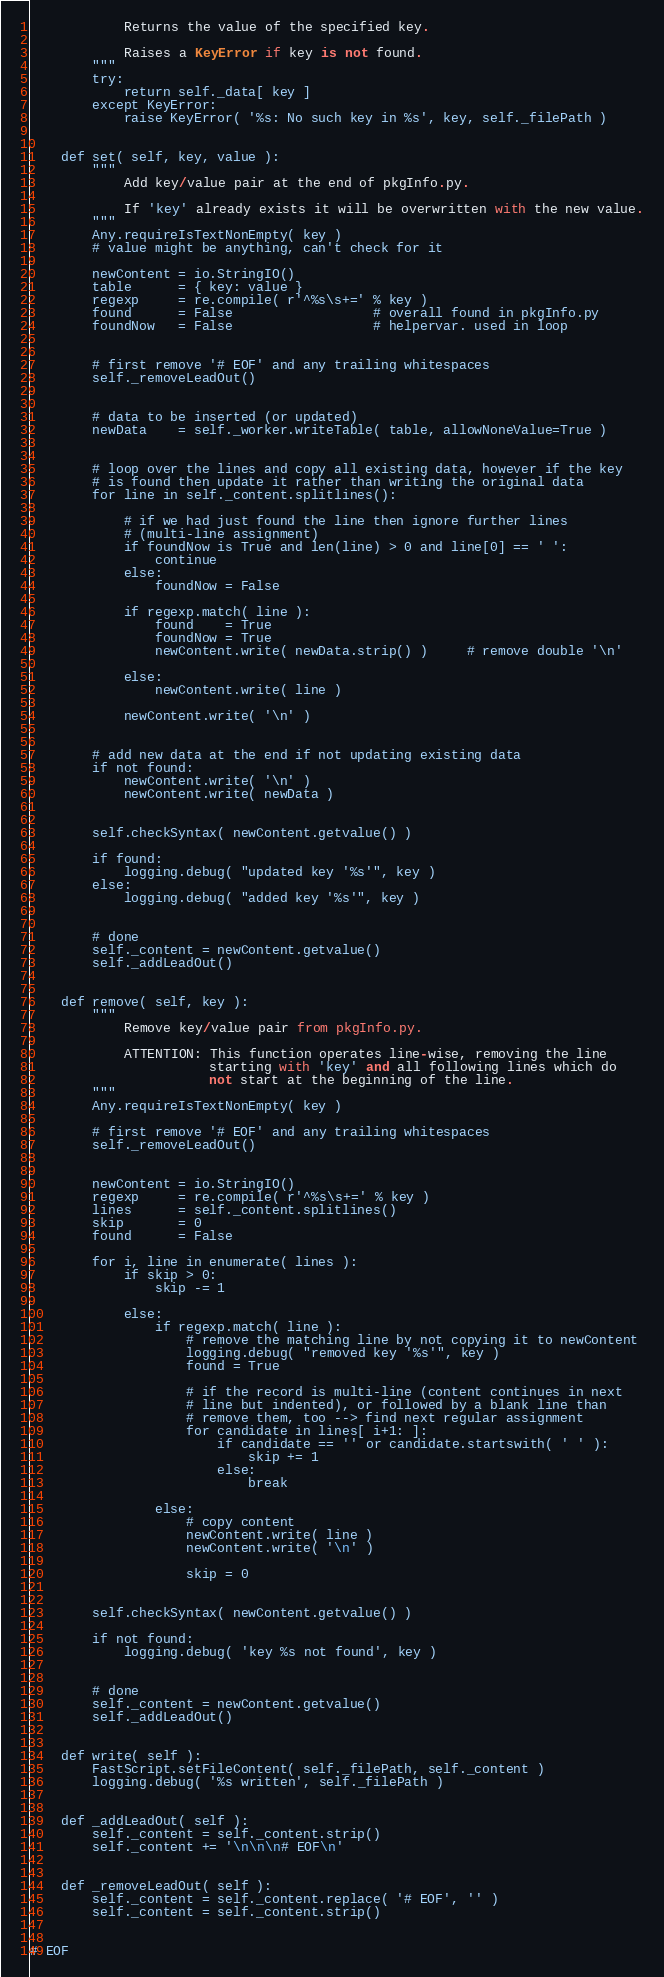Convert code to text. <code><loc_0><loc_0><loc_500><loc_500><_Python_>            Returns the value of the specified key.

            Raises a KeyError if key is not found.
        """
        try:
            return self._data[ key ]
        except KeyError:
            raise KeyError( '%s: No such key in %s', key, self._filePath )


    def set( self, key, value ):
        """
            Add key/value pair at the end of pkgInfo.py.

            If 'key' already exists it will be overwritten with the new value.
        """
        Any.requireIsTextNonEmpty( key )
        # value might be anything, can't check for it

        newContent = io.StringIO()
        table      = { key: value }
        regexp     = re.compile( r'^%s\s+=' % key )
        found      = False                  # overall found in pkgInfo.py
        foundNow   = False                  # helpervar. used in loop


        # first remove '# EOF' and any trailing whitespaces
        self._removeLeadOut()


        # data to be inserted (or updated)
        newData    = self._worker.writeTable( table, allowNoneValue=True )


        # loop over the lines and copy all existing data, however if the key
        # is found then update it rather than writing the original data
        for line in self._content.splitlines():

            # if we had just found the line then ignore further lines
            # (multi-line assignment)
            if foundNow is True and len(line) > 0 and line[0] == ' ':
                continue
            else:
                foundNow = False

            if regexp.match( line ):
                found    = True
                foundNow = True
                newContent.write( newData.strip() )     # remove double '\n'

            else:
                newContent.write( line )

            newContent.write( '\n' )


        # add new data at the end if not updating existing data
        if not found:
            newContent.write( '\n' )
            newContent.write( newData )


        self.checkSyntax( newContent.getvalue() )

        if found:
            logging.debug( "updated key '%s'", key )
        else:
            logging.debug( "added key '%s'", key )


        # done
        self._content = newContent.getvalue()
        self._addLeadOut()


    def remove( self, key ):
        """
            Remove key/value pair from pkgInfo.py.

            ATTENTION: This function operates line-wise, removing the line
                       starting with 'key' and all following lines which do
                       not start at the beginning of the line.
        """
        Any.requireIsTextNonEmpty( key )

        # first remove '# EOF' and any trailing whitespaces
        self._removeLeadOut()


        newContent = io.StringIO()
        regexp     = re.compile( r'^%s\s+=' % key )
        lines      = self._content.splitlines()
        skip       = 0
        found      = False

        for i, line in enumerate( lines ):
            if skip > 0:
                skip -= 1

            else:
                if regexp.match( line ):
                    # remove the matching line by not copying it to newContent
                    logging.debug( "removed key '%s'", key )
                    found = True

                    # if the record is multi-line (content continues in next
                    # line but indented), or followed by a blank line than
                    # remove them, too --> find next regular assignment
                    for candidate in lines[ i+1: ]:
                        if candidate == '' or candidate.startswith( ' ' ):
                            skip += 1
                        else:
                            break

                else:
                    # copy content
                    newContent.write( line )
                    newContent.write( '\n' )

                    skip = 0


        self.checkSyntax( newContent.getvalue() )

        if not found:
            logging.debug( 'key %s not found', key )


        # done
        self._content = newContent.getvalue()
        self._addLeadOut()


    def write( self ):
        FastScript.setFileContent( self._filePath, self._content )
        logging.debug( '%s written', self._filePath )


    def _addLeadOut( self ):
        self._content = self._content.strip()
        self._content += '\n\n\n# EOF\n'


    def _removeLeadOut( self ):
        self._content = self._content.replace( '# EOF', '' )
        self._content = self._content.strip()


# EOF
</code> 